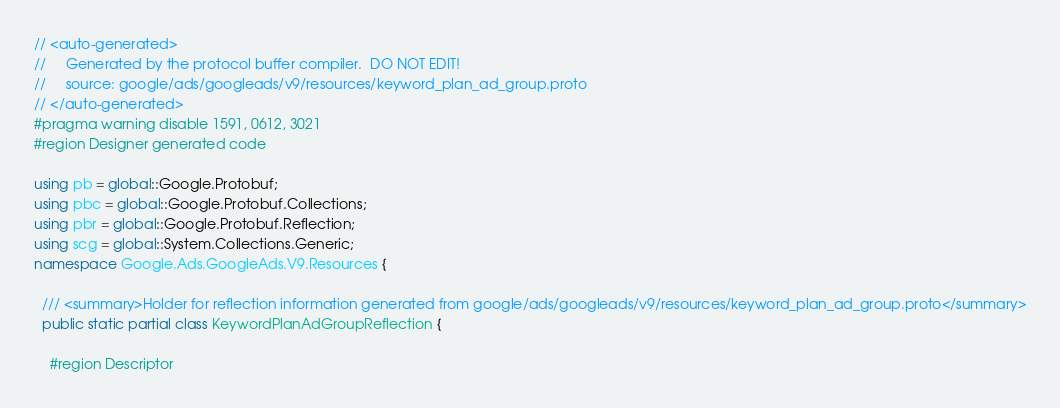<code> <loc_0><loc_0><loc_500><loc_500><_C#_>// <auto-generated>
//     Generated by the protocol buffer compiler.  DO NOT EDIT!
//     source: google/ads/googleads/v9/resources/keyword_plan_ad_group.proto
// </auto-generated>
#pragma warning disable 1591, 0612, 3021
#region Designer generated code

using pb = global::Google.Protobuf;
using pbc = global::Google.Protobuf.Collections;
using pbr = global::Google.Protobuf.Reflection;
using scg = global::System.Collections.Generic;
namespace Google.Ads.GoogleAds.V9.Resources {

  /// <summary>Holder for reflection information generated from google/ads/googleads/v9/resources/keyword_plan_ad_group.proto</summary>
  public static partial class KeywordPlanAdGroupReflection {

    #region Descriptor</code> 